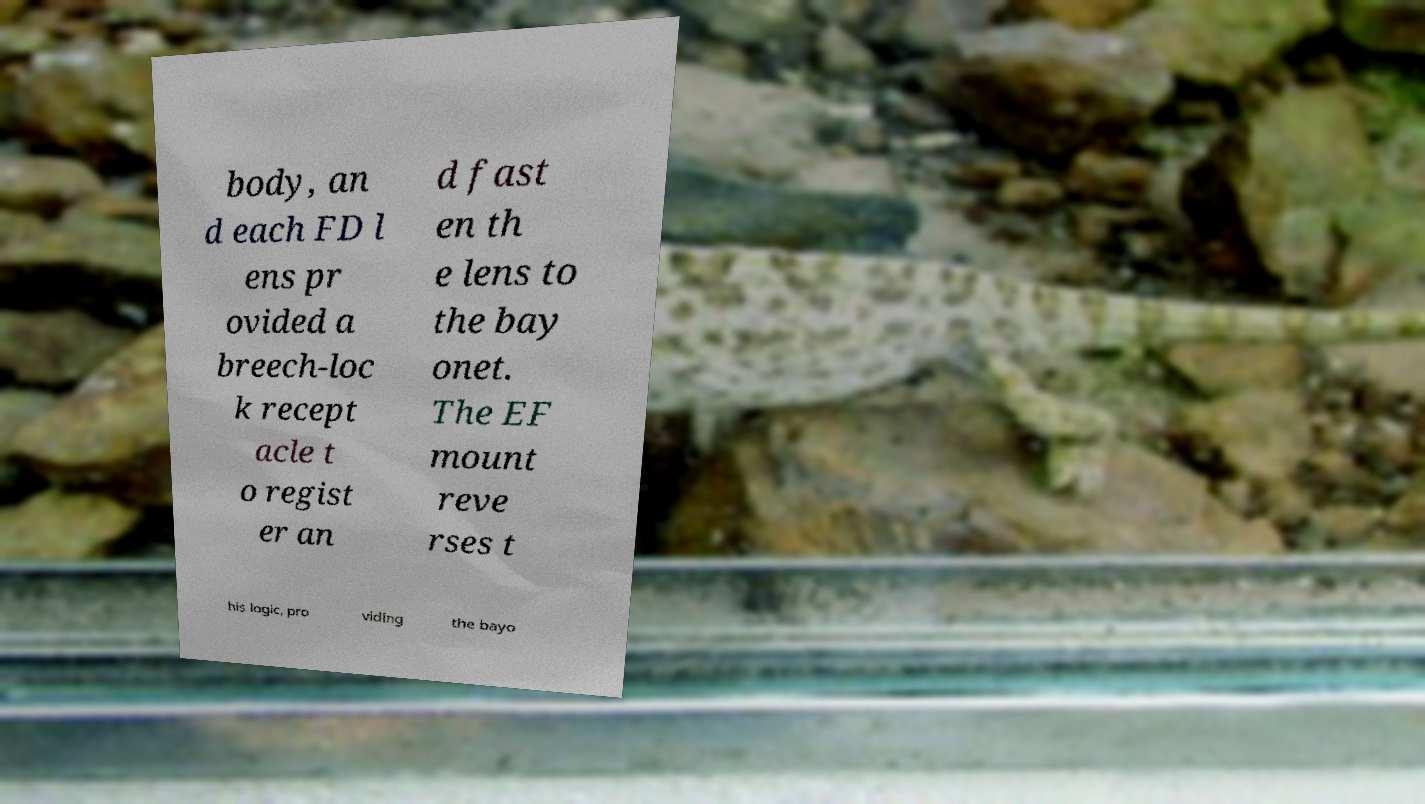Can you accurately transcribe the text from the provided image for me? body, an d each FD l ens pr ovided a breech-loc k recept acle t o regist er an d fast en th e lens to the bay onet. The EF mount reve rses t his logic, pro viding the bayo 